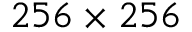<formula> <loc_0><loc_0><loc_500><loc_500>2 5 6 \times 2 5 6</formula> 